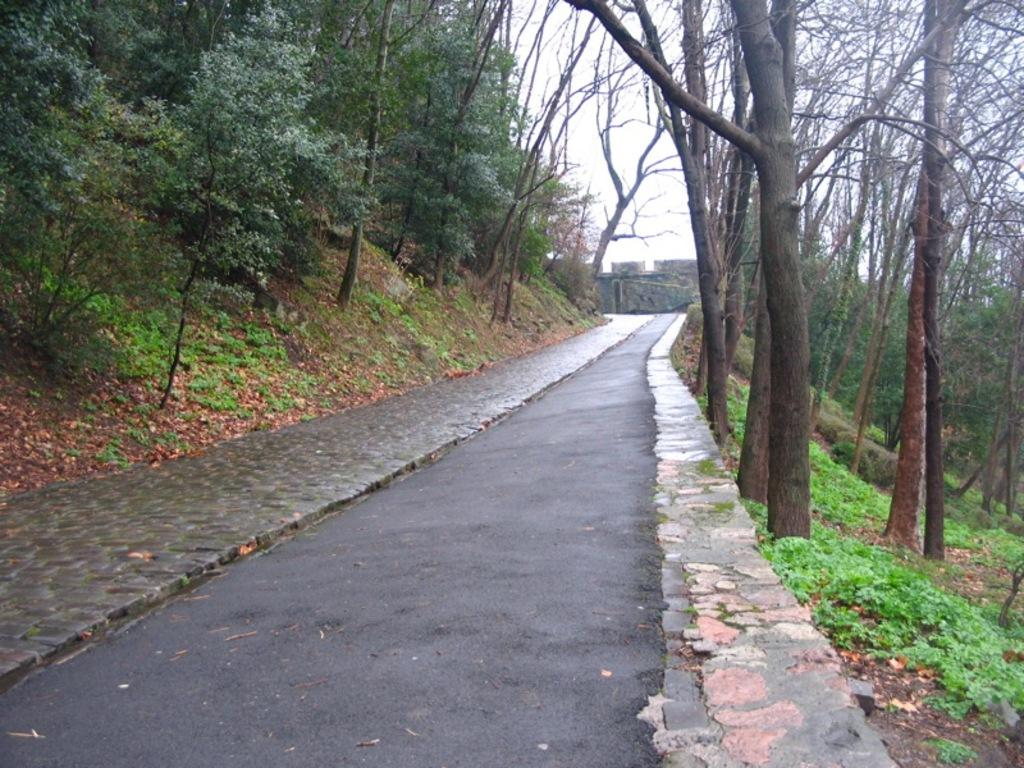What is the main feature in the center of the image? There is a road in the center of the image. What can be seen on the left side of the image? There are trees on the left side of the image. What is present on the right side of the image? There are trees on the right side of the image. What type of vegetation is visible in the image? Plants are present in the image. What else can be seen on the ground in the image? Dry leaves are visible in the image. What is visible at the top of the image? The sky is visible at the top of the image. What type of brick is used to build the plot in the image? There is no plot or brick present in the image; it features a road, trees, plants, dry leaves, and the sky. 